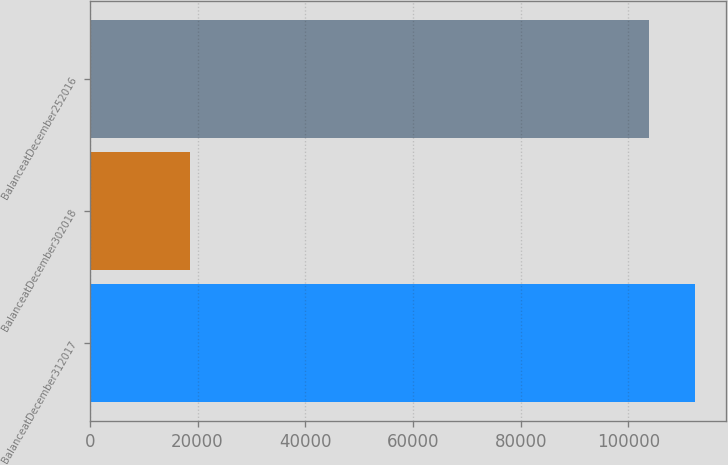Convert chart to OTSL. <chart><loc_0><loc_0><loc_500><loc_500><bar_chart><fcel>BalanceatDecember312017<fcel>BalanceatDecember302018<fcel>BalanceatDecember252016<nl><fcel>112428<fcel>18542<fcel>103744<nl></chart> 